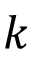<formula> <loc_0><loc_0><loc_500><loc_500>k</formula> 